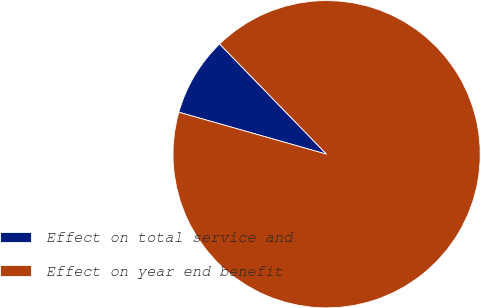Convert chart to OTSL. <chart><loc_0><loc_0><loc_500><loc_500><pie_chart><fcel>Effect on total service and<fcel>Effect on year end benefit<nl><fcel>8.33%<fcel>91.67%<nl></chart> 